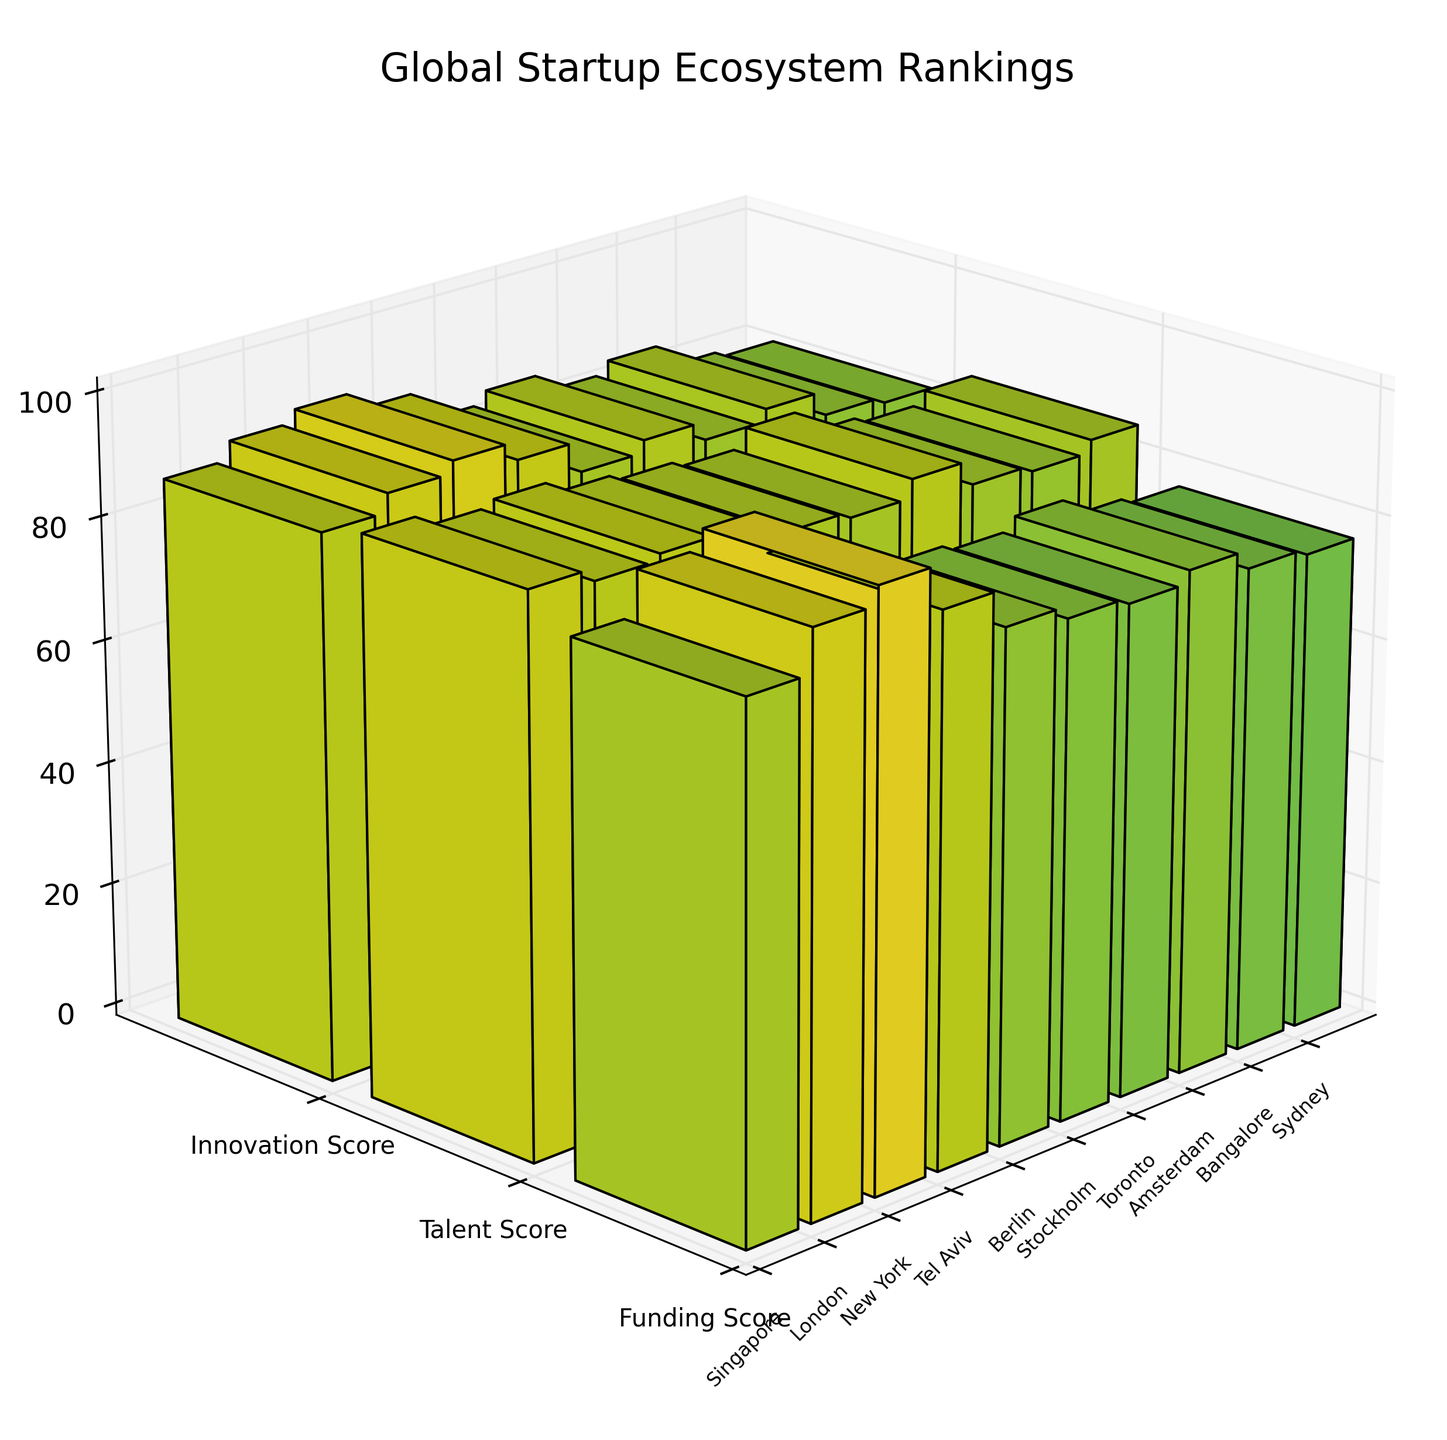what is the title of the figure? The title of the figure is displayed at the top of the plot to describe what the figure is about. In this 3D voxel plot, the title clearly indicates the subject of the figure.
Answer: Global Startup Ecosystem Rankings Which city has the highest funding score? To determine the city with the highest funding score, we look at the bar heights in the 'funding score' category, and we note the city that reaches the highest point.
Answer: New York How many cities are evaluated in the figure? The figure uses different bars to represent different cities along one axis. By counting the labels, we can determine the number of cities evaluated.
Answer: 10 What is the difference in innovation score between New York and Sydney? To find the difference in innovation scores between New York and Sydney, we locate their corresponding bars in the 'Innovation Score' section, note their heights, and subtract the smaller value from the larger.
Answer: 12 (93 - 81) Which city has the lowest talent score and what is that score? By examining the heights of the bars in the talent score category, we can see which city has the shortest bar for talent score.
Answer: Bangalore; 83 Which parameter generally has the highest scores across all cities? By visually comparing the bar heights across all categories (funding, talent, innovation), we look for the category with consistently higher bars across multiple cities.
Answer: Funding What is the average innovation score for Berlin and Stockholm? To find the average, we sum the innovation scores for both cities (85 and 87) and divide by the number of cities.
Answer: 86 ( (85+87)/2 ) Which city has the most balanced scores across all three parameters? To identify the city with the most balanced scores, we look for bars with similar heights across all three categories for each city.
Answer: Tel Aviv Compare the funding score of London and Bangalore. Which city has a greater score and by how much? To compare the funding scores, we locate the funding score bars for London and Bangalore, identify their heights, and subtract the smaller value from the larger. London has a higher funding score than Bangalore.
Answer: London; 14 (92 - 78) What are the y-axis labels, and what do they represent? The y-axis labels are located along the vertical depth axis and represent the category of scores evaluated in the figure. These labels are 'Funding Score,' 'Talent Score,' and 'Innovation Score.'
Answer: Funding Score, Talent Score, Innovation Score 